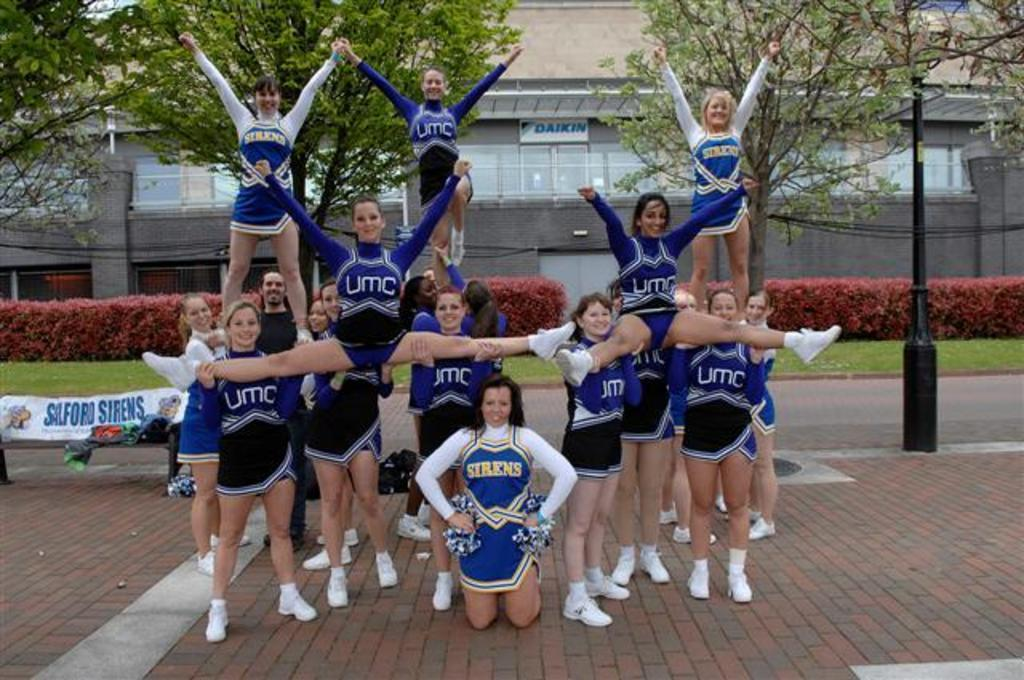<image>
Provide a brief description of the given image. A group of UMC cheerleaders practice their routines together. 